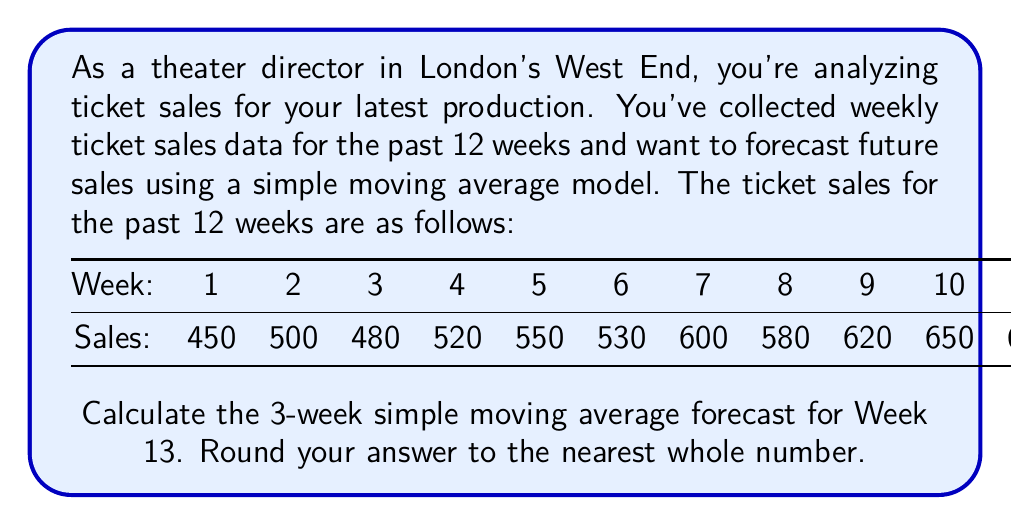Solve this math problem. To calculate the 3-week simple moving average forecast for Week 13, we need to follow these steps:

1. Identify the last 3 weeks of data (Weeks 10, 11, and 12).
2. Calculate the average of these 3 weeks.

The formula for a 3-week simple moving average is:

$$ SMA_3 = \frac{x_{t-2} + x_{t-1} + x_t}{3} $$

Where $x_t$ represents the sales value at time $t$.

For our forecast:
$x_{10} = 650$
$x_{11} = 670$
$x_{12} = 700$

Plugging these values into the formula:

$$ SMA_3 = \frac{650 + 670 + 700}{3} = \frac{2020}{3} = 673.33 $$

Rounding to the nearest whole number: 673
Answer: 673 tickets 